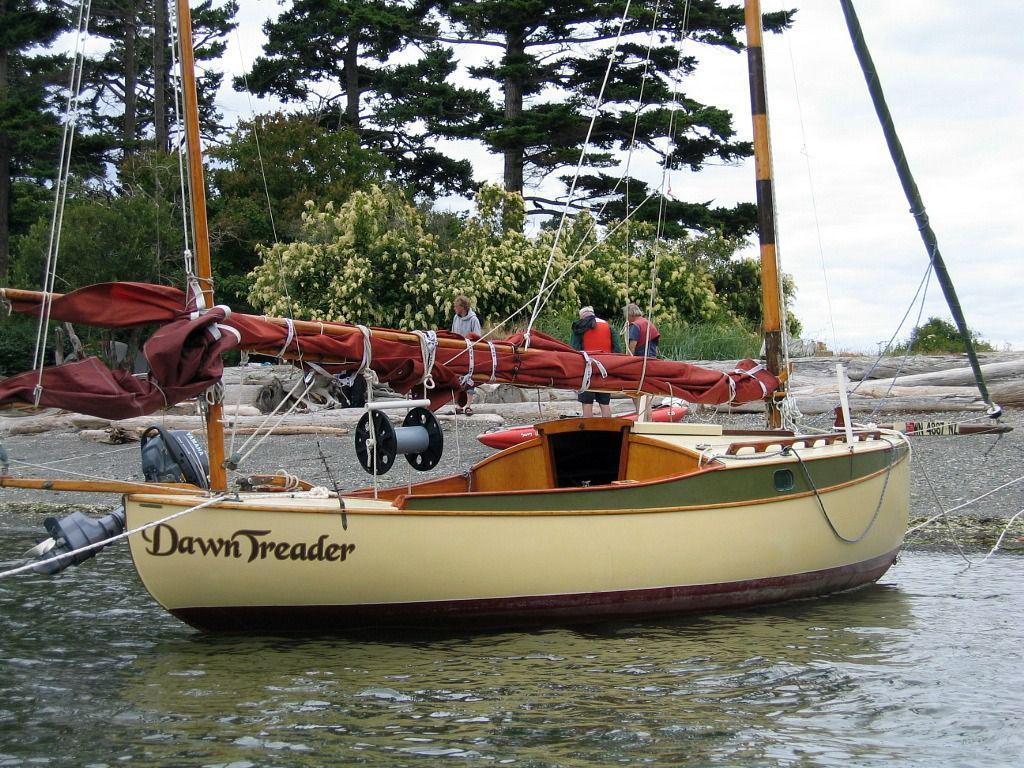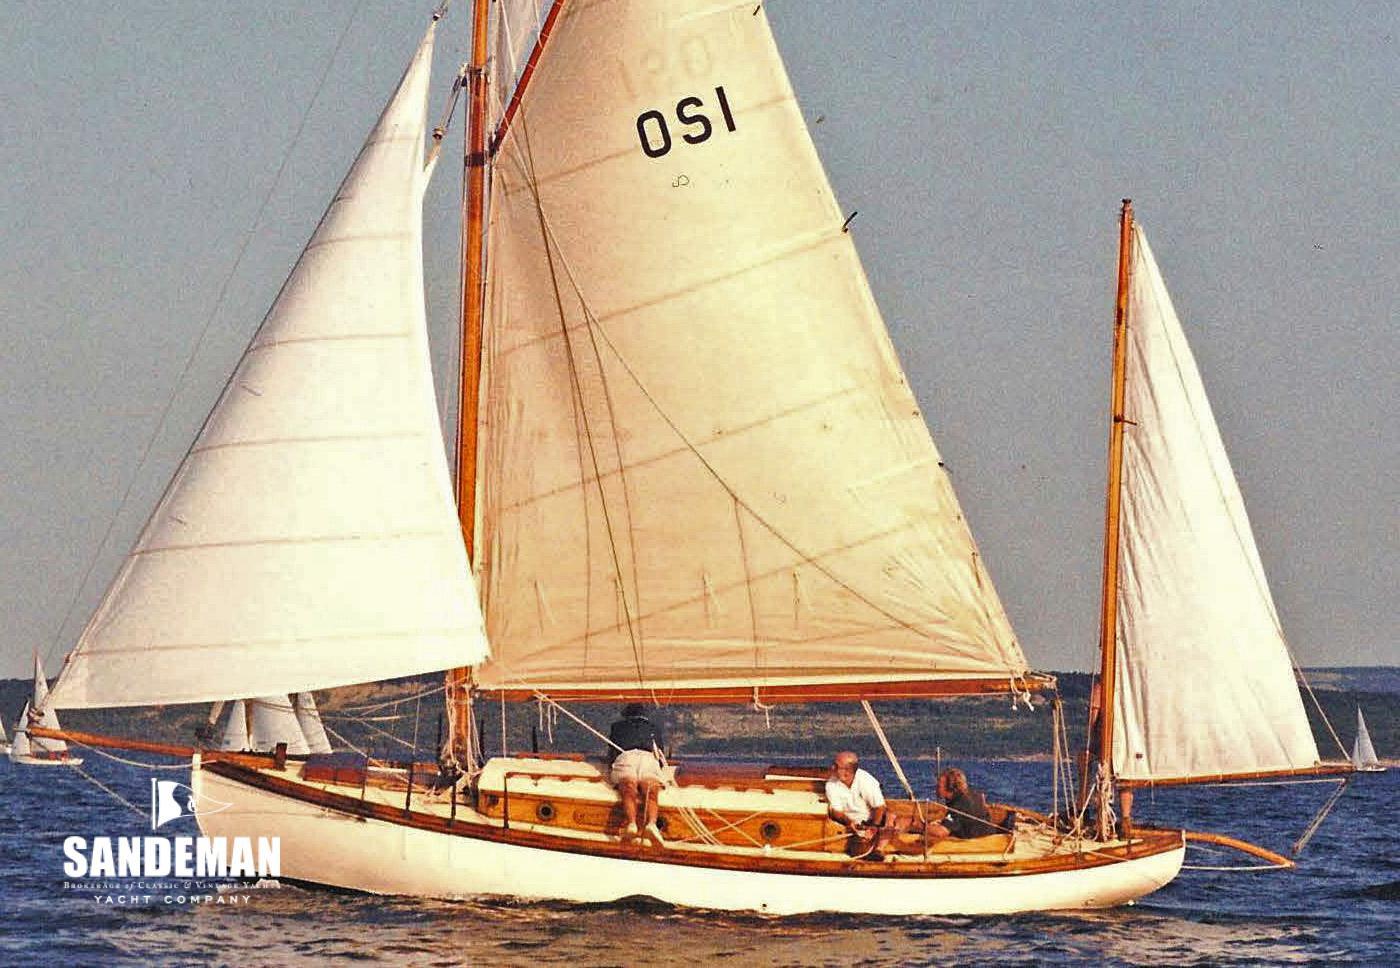The first image is the image on the left, the second image is the image on the right. For the images shown, is this caption "The boat in the right image has its sails up." true? Answer yes or no. Yes. 